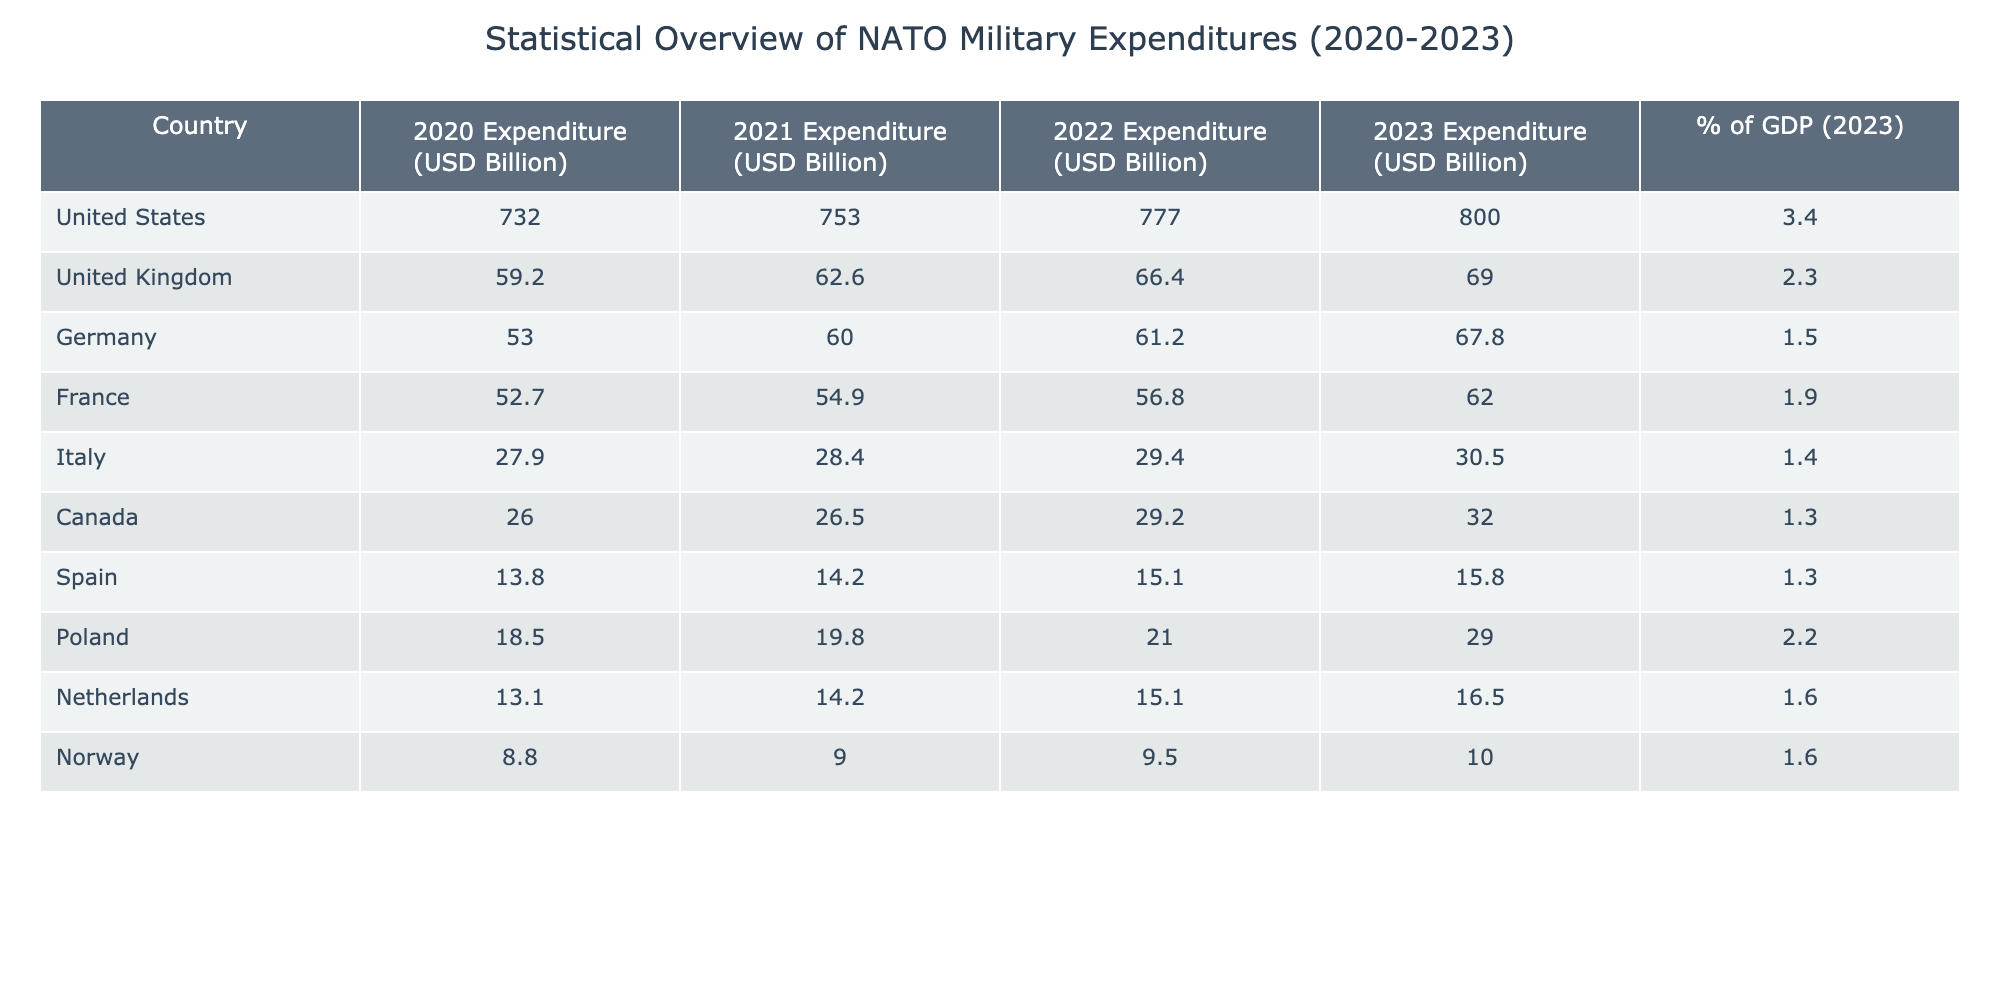What is the military expenditure of Canada in 2023? The table shows that Canada's military expenditure for 2023 is listed as 32.0 USD Billion.
Answer: 32.0 USD Billion Which NATO member country had the highest military expenditure in 2022? The table indicates that the United States had the highest military expenditure in 2022 with 777.0 USD Billion, which is greater than all other listed countries.
Answer: United States What was the percentage increase in military expenditure for Germany from 2020 to 2023? To calculate the percentage increase from Germany’s 2020 expenditure of 53.0 to 67.8 in 2023, we find the difference (67.8 - 53.0 = 14.8) and then divide by the original value (14.8 / 53.0), finally multiplying by 100 gives approximately 27.92%.
Answer: Approximately 27.9% Is the military expenditure of Italy greater than that of Spain in 2022? The table provides Italy's expenditure for 2022 as 29.4 USD Billion, while Spain's is 15.1 USD Billion; since 29.4 is greater than 15.1, the statement is true.
Answer: Yes What is the total military expenditure of the United Kingdom and France in 2021? The table shows the UK expenditure for 2021 is 62.6 USD Billion and France's is 54.9 USD Billion. Summing these values gives 62.6 + 54.9 = 117.5 USD Billion.
Answer: 117.5 USD Billion Which country, among the listed NATO members, spends the least on military expenditures in 2023? Looking at the 2023 column, the expenditures from lowest to highest shows Norway at 10.0 USD Billion as the least when comparing against Spain's 15.8 USD Billion and others.
Answer: Norway What was the military expenditure of Poland in 2021? The table lists Poland's military expenditure for 2021 as 19.8 USD Billion. This information is specified directly in the table.
Answer: 19.8 USD Billion Is the expenditure of the United States in 2020 more than the total military expenditure of Norway from 2020 to 2023? The US expenditure in 2020 is 732.0 USD Billion. Adding Norway's expenditures for 2020 (8.8), 2021 (9.0), 2022 (9.5), and 2023 (10.0) gives a total of 37.3 USD Billion. Since 732.0 is greater than 37.3, the statement is true.
Answer: Yes 